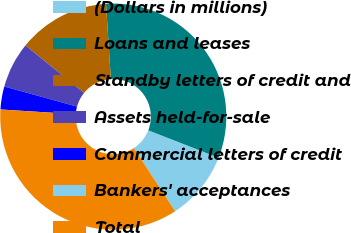Convert chart. <chart><loc_0><loc_0><loc_500><loc_500><pie_chart><fcel>(Dollars in millions)<fcel>Loans and leases<fcel>Standby letters of credit and<fcel>Assets held-for-sale<fcel>Commercial letters of credit<fcel>Bankers' acceptances<fcel>Total<nl><fcel>9.85%<fcel>31.95%<fcel>13.13%<fcel>6.56%<fcel>3.28%<fcel>0.0%<fcel>35.23%<nl></chart> 